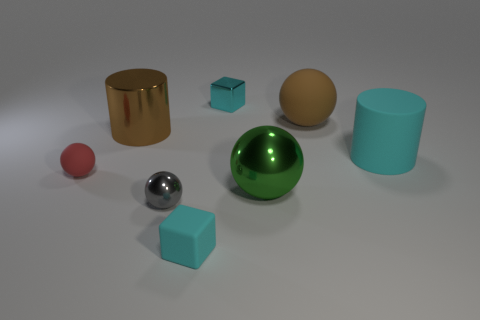Subtract all big shiny spheres. How many spheres are left? 3 Subtract 1 balls. How many balls are left? 3 Add 1 shiny blocks. How many objects exist? 9 Subtract all brown spheres. How many spheres are left? 3 Subtract all purple spheres. Subtract all blue cubes. How many spheres are left? 4 Add 1 small cyan matte blocks. How many small cyan matte blocks are left? 2 Add 2 brown spheres. How many brown spheres exist? 3 Subtract 0 brown cubes. How many objects are left? 8 Subtract all cylinders. How many objects are left? 6 Subtract all gray shiny balls. Subtract all rubber blocks. How many objects are left? 6 